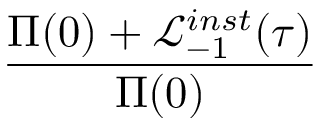<formula> <loc_0><loc_0><loc_500><loc_500>\frac { \Pi ( 0 ) + \mathcal { L } _ { - 1 } ^ { i n s t } ( \tau ) } { \Pi ( 0 ) }</formula> 